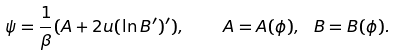<formula> <loc_0><loc_0><loc_500><loc_500>\psi = \frac { 1 } { \beta } ( A + 2 u ( \ln B ^ { \prime } ) ^ { \prime } ) , \quad A = A ( \phi ) , \ B = B ( \phi ) .</formula> 